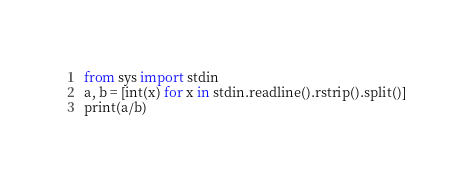Convert code to text. <code><loc_0><loc_0><loc_500><loc_500><_Python_>from sys import stdin
a, b = [int(x) for x in stdin.readline().rstrip().split()]
print(a/b)</code> 